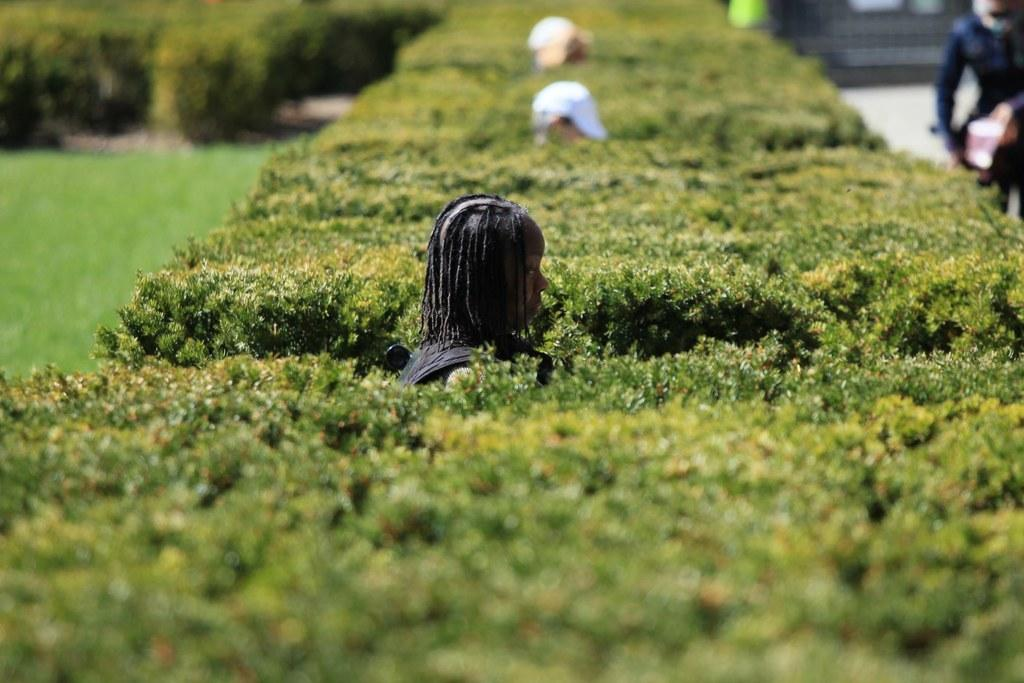What can be observed about the people in the image? There are people standing in the image. Can you describe the clothing of one of the individuals? A man is wearing a cap in the image. What type of natural environment is visible in the image? There are trees visible in the image, and there is grass on the ground. How many human figures can be seen in the image? There is a human standing on the side in the image, in addition to the other people. What type of wood can be seen growing among the flowers in the image? There is no wood or flowers present in the image; it features people and a natural environment with trees and grass. 